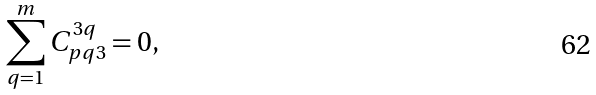Convert formula to latex. <formula><loc_0><loc_0><loc_500><loc_500>\sum _ { q = 1 } ^ { m } C _ { p q 3 } ^ { 3 q } = 0 ,</formula> 